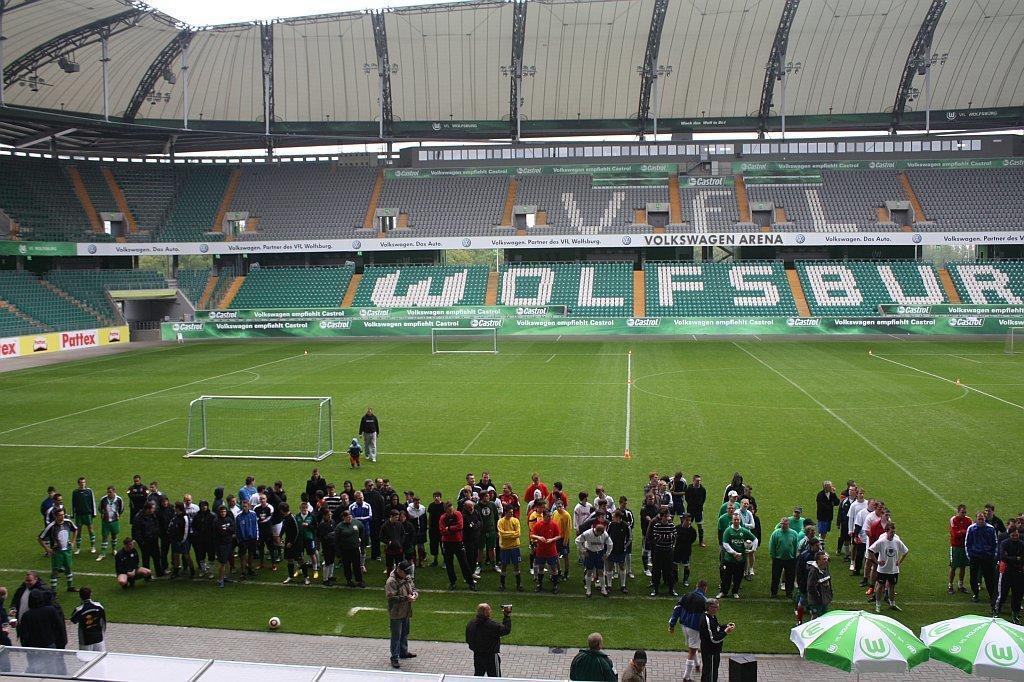Could you give a brief overview of what you see in this image? In the given image i can see the inside view of the stadium that includes people,boards and some other objects. 